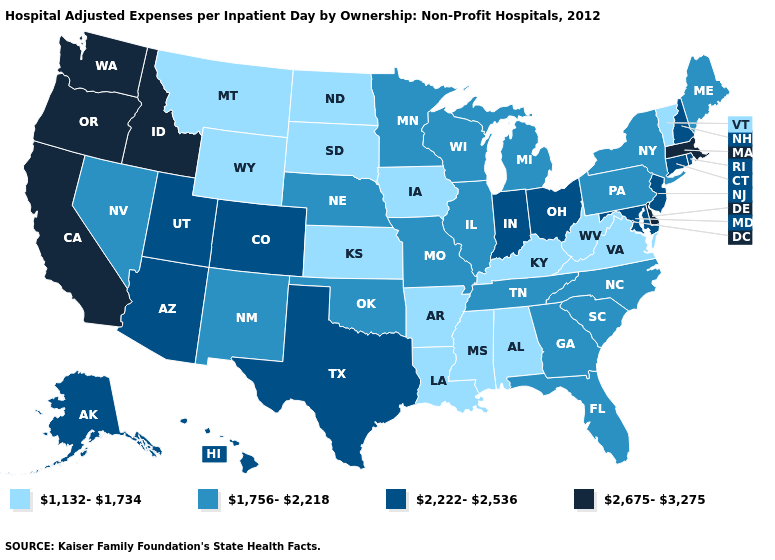Does the map have missing data?
Answer briefly. No. Name the states that have a value in the range 2,675-3,275?
Quick response, please. California, Delaware, Idaho, Massachusetts, Oregon, Washington. Which states have the highest value in the USA?
Give a very brief answer. California, Delaware, Idaho, Massachusetts, Oregon, Washington. Is the legend a continuous bar?
Answer briefly. No. Name the states that have a value in the range 1,756-2,218?
Give a very brief answer. Florida, Georgia, Illinois, Maine, Michigan, Minnesota, Missouri, Nebraska, Nevada, New Mexico, New York, North Carolina, Oklahoma, Pennsylvania, South Carolina, Tennessee, Wisconsin. Name the states that have a value in the range 1,132-1,734?
Quick response, please. Alabama, Arkansas, Iowa, Kansas, Kentucky, Louisiana, Mississippi, Montana, North Dakota, South Dakota, Vermont, Virginia, West Virginia, Wyoming. Among the states that border Colorado , which have the highest value?
Write a very short answer. Arizona, Utah. What is the value of Utah?
Give a very brief answer. 2,222-2,536. Name the states that have a value in the range 2,675-3,275?
Quick response, please. California, Delaware, Idaho, Massachusetts, Oregon, Washington. Name the states that have a value in the range 1,132-1,734?
Be succinct. Alabama, Arkansas, Iowa, Kansas, Kentucky, Louisiana, Mississippi, Montana, North Dakota, South Dakota, Vermont, Virginia, West Virginia, Wyoming. What is the highest value in states that border New Jersey?
Be succinct. 2,675-3,275. What is the value of Connecticut?
Give a very brief answer. 2,222-2,536. Does Idaho have the highest value in the USA?
Give a very brief answer. Yes. Which states have the highest value in the USA?
Short answer required. California, Delaware, Idaho, Massachusetts, Oregon, Washington. Does Washington have the highest value in the USA?
Short answer required. Yes. 